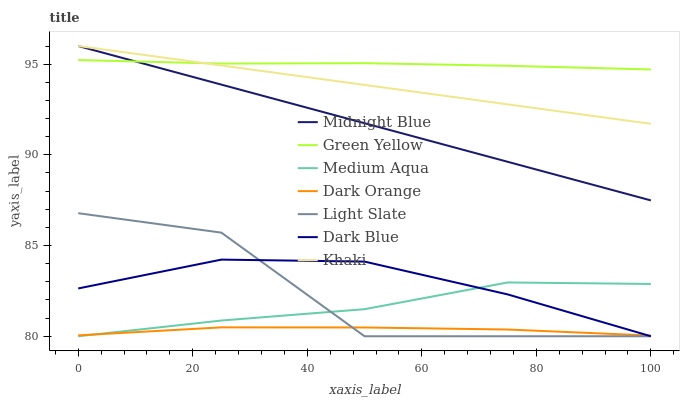Does Dark Orange have the minimum area under the curve?
Answer yes or no. Yes. Does Green Yellow have the maximum area under the curve?
Answer yes or no. Yes. Does Khaki have the minimum area under the curve?
Answer yes or no. No. Does Khaki have the maximum area under the curve?
Answer yes or no. No. Is Midnight Blue the smoothest?
Answer yes or no. Yes. Is Light Slate the roughest?
Answer yes or no. Yes. Is Khaki the smoothest?
Answer yes or no. No. Is Khaki the roughest?
Answer yes or no. No. Does Light Slate have the lowest value?
Answer yes or no. Yes. Does Khaki have the lowest value?
Answer yes or no. No. Does Midnight Blue have the highest value?
Answer yes or no. Yes. Does Light Slate have the highest value?
Answer yes or no. No. Is Dark Orange less than Midnight Blue?
Answer yes or no. Yes. Is Green Yellow greater than Dark Orange?
Answer yes or no. Yes. Does Dark Blue intersect Light Slate?
Answer yes or no. Yes. Is Dark Blue less than Light Slate?
Answer yes or no. No. Is Dark Blue greater than Light Slate?
Answer yes or no. No. Does Dark Orange intersect Midnight Blue?
Answer yes or no. No. 